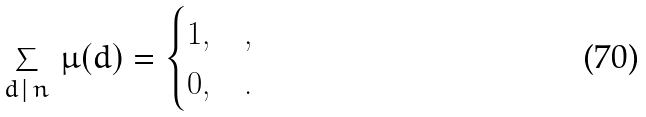<formula> <loc_0><loc_0><loc_500><loc_500>\sum _ { d \, | \, n } \, \mu ( d ) & = \begin{cases} 1 , & , \\ 0 , & . \end{cases}</formula> 